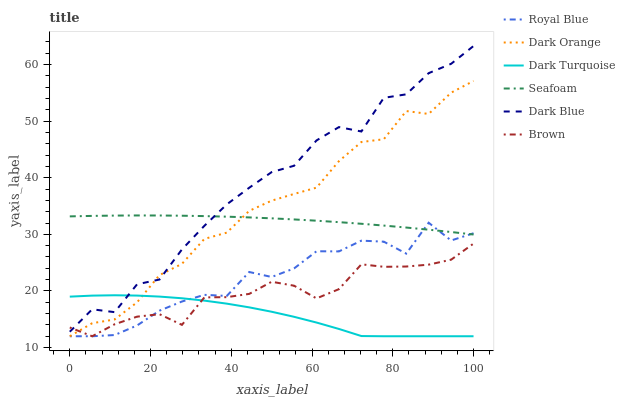Does Dark Turquoise have the minimum area under the curve?
Answer yes or no. Yes. Does Dark Blue have the maximum area under the curve?
Answer yes or no. Yes. Does Dark Blue have the minimum area under the curve?
Answer yes or no. No. Does Dark Turquoise have the maximum area under the curve?
Answer yes or no. No. Is Seafoam the smoothest?
Answer yes or no. Yes. Is Dark Blue the roughest?
Answer yes or no. Yes. Is Dark Turquoise the smoothest?
Answer yes or no. No. Is Dark Turquoise the roughest?
Answer yes or no. No. Does Brown have the lowest value?
Answer yes or no. Yes. Does Dark Blue have the lowest value?
Answer yes or no. No. Does Dark Blue have the highest value?
Answer yes or no. Yes. Does Dark Turquoise have the highest value?
Answer yes or no. No. Is Brown less than Seafoam?
Answer yes or no. Yes. Is Dark Blue greater than Royal Blue?
Answer yes or no. Yes. Does Dark Orange intersect Brown?
Answer yes or no. Yes. Is Dark Orange less than Brown?
Answer yes or no. No. Is Dark Orange greater than Brown?
Answer yes or no. No. Does Brown intersect Seafoam?
Answer yes or no. No. 